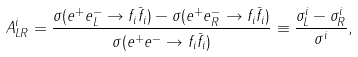<formula> <loc_0><loc_0><loc_500><loc_500>A ^ { i } _ { L R } = \frac { \sigma ( e ^ { + } e ^ { - } _ { L } \to f _ { i } \bar { f } _ { i } ) - \sigma ( e ^ { + } e ^ { - } _ { R } \to f _ { i } \bar { f } _ { i } ) } { \sigma ( e ^ { + } e ^ { - } \to f _ { i } \bar { f } _ { i } ) } \equiv \frac { \sigma ^ { i } _ { L } - \sigma ^ { i } _ { R } } { \sigma ^ { i } } ,</formula> 